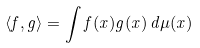<formula> <loc_0><loc_0><loc_500><loc_500>\langle f , g \rangle = \int f ( x ) g ( x ) \, d \mu ( x )</formula> 